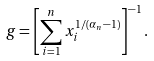<formula> <loc_0><loc_0><loc_500><loc_500>g = \left [ \sum _ { i = 1 } ^ { n } x _ { i } ^ { 1 / ( \alpha _ { n } - 1 ) } \right ] ^ { - 1 } .</formula> 